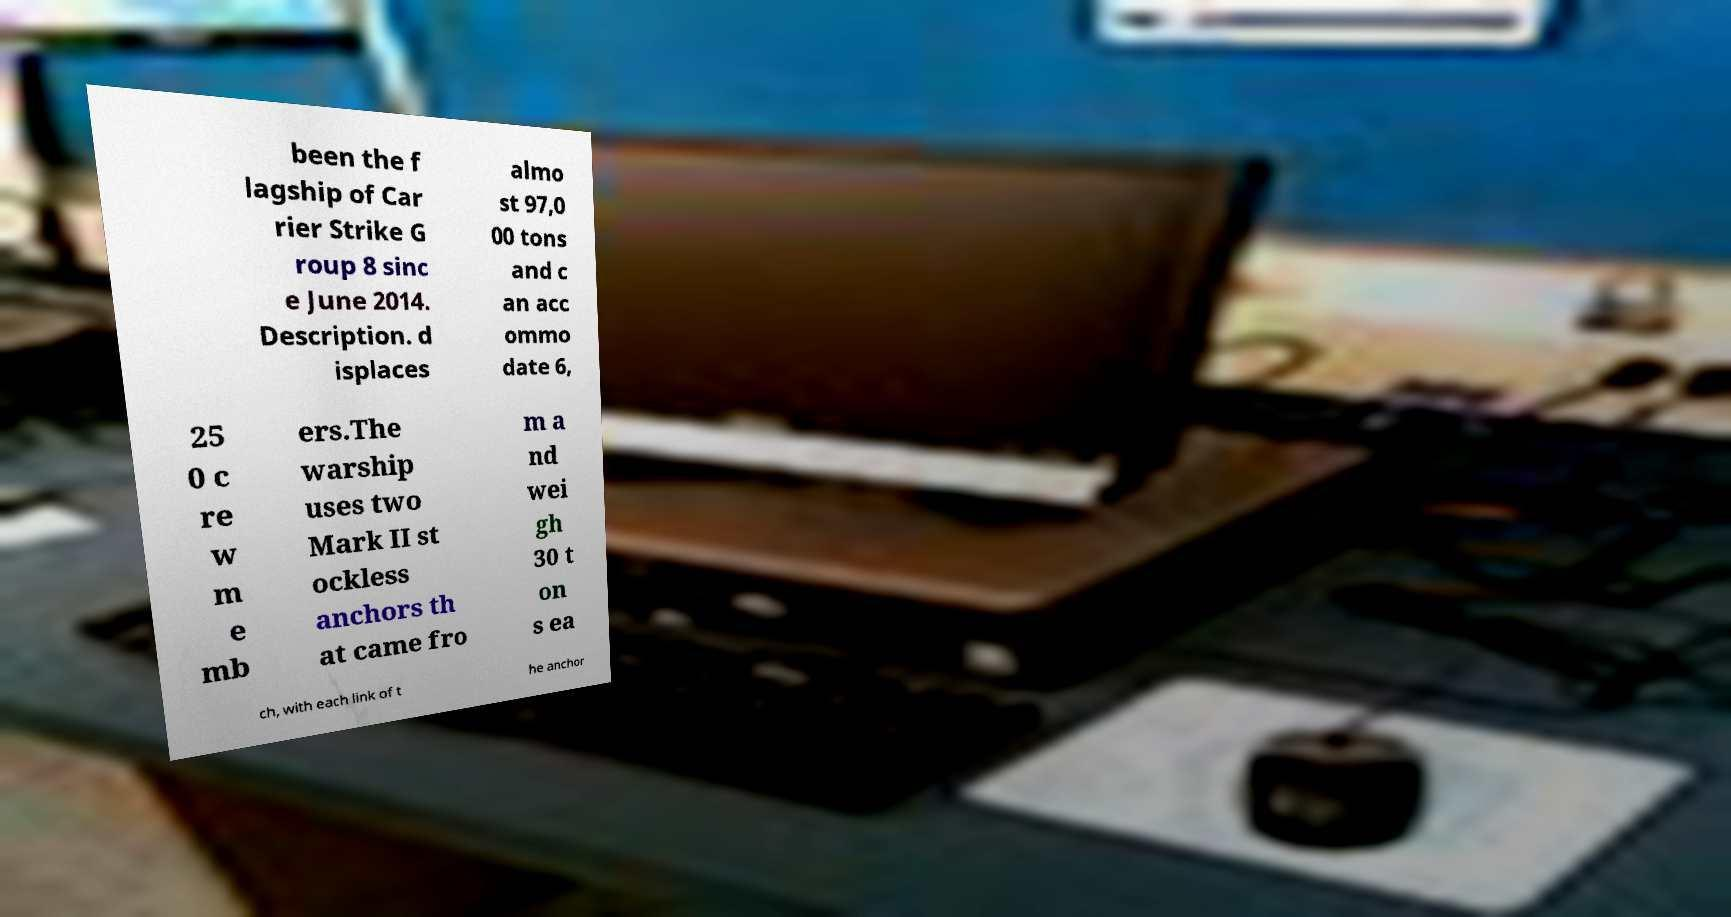There's text embedded in this image that I need extracted. Can you transcribe it verbatim? been the f lagship of Car rier Strike G roup 8 sinc e June 2014. Description. d isplaces almo st 97,0 00 tons and c an acc ommo date 6, 25 0 c re w m e mb ers.The warship uses two Mark II st ockless anchors th at came fro m a nd wei gh 30 t on s ea ch, with each link of t he anchor 